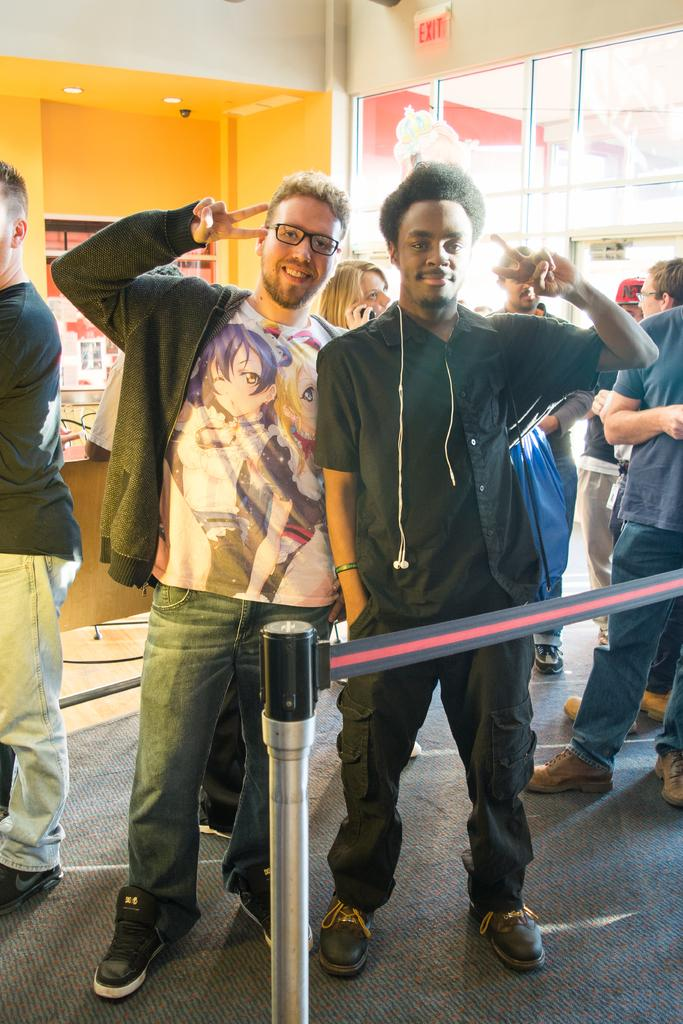What is the main subject of the image? The main subject of the image is the persons standing on the floor. What can be seen in the background of the image? In the background, there is a wall, lights, glasses, and a board. Can you describe the wall in the background? The wall is a part of the background and does not have any specific details mentioned in the facts. What type of bomb is being used in the war depicted in the image? There is no depiction of a war or any bomb in the image; it features persons standing on the floor with a background containing a wall, lights, glasses, and a board. 